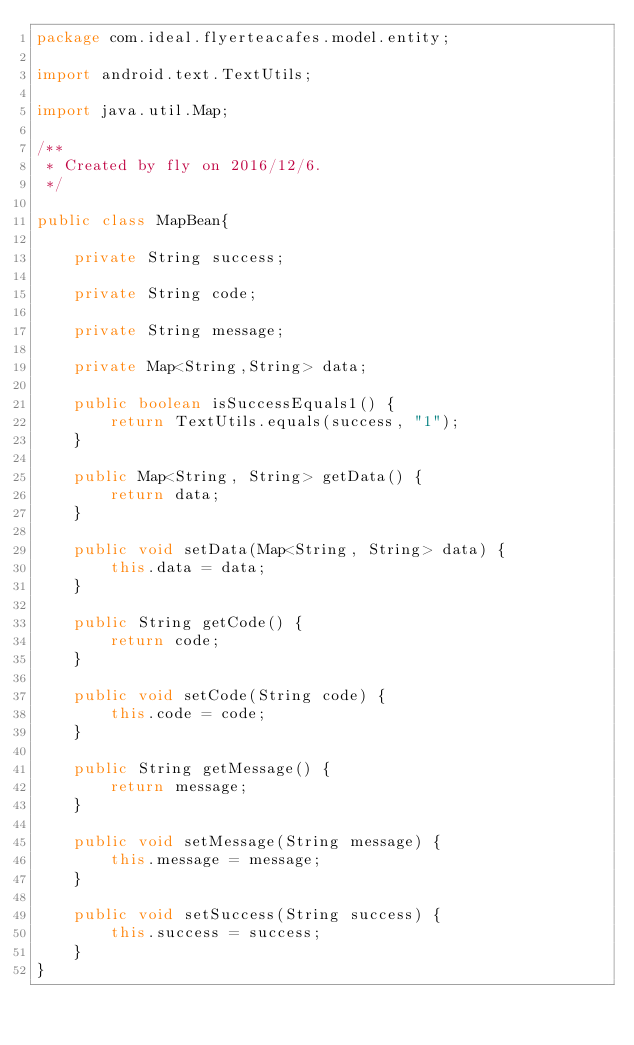Convert code to text. <code><loc_0><loc_0><loc_500><loc_500><_Java_>package com.ideal.flyerteacafes.model.entity;

import android.text.TextUtils;

import java.util.Map;

/**
 * Created by fly on 2016/12/6.
 */

public class MapBean{

    private String success;

    private String code;

    private String message;

    private Map<String,String> data;

    public boolean isSuccessEquals1() {
        return TextUtils.equals(success, "1");
    }

    public Map<String, String> getData() {
        return data;
    }

    public void setData(Map<String, String> data) {
        this.data = data;
    }

    public String getCode() {
        return code;
    }

    public void setCode(String code) {
        this.code = code;
    }

    public String getMessage() {
        return message;
    }

    public void setMessage(String message) {
        this.message = message;
    }

    public void setSuccess(String success) {
        this.success = success;
    }
}
</code> 